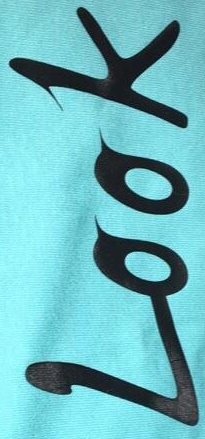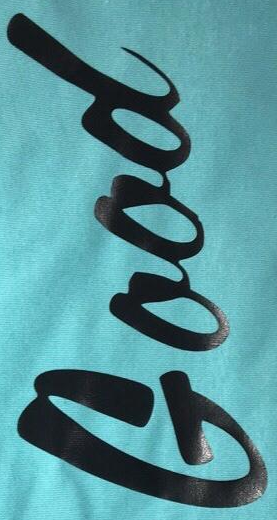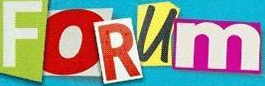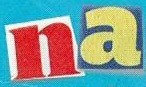What words can you see in these images in sequence, separated by a semicolon? Look; Good; FORUm; na 